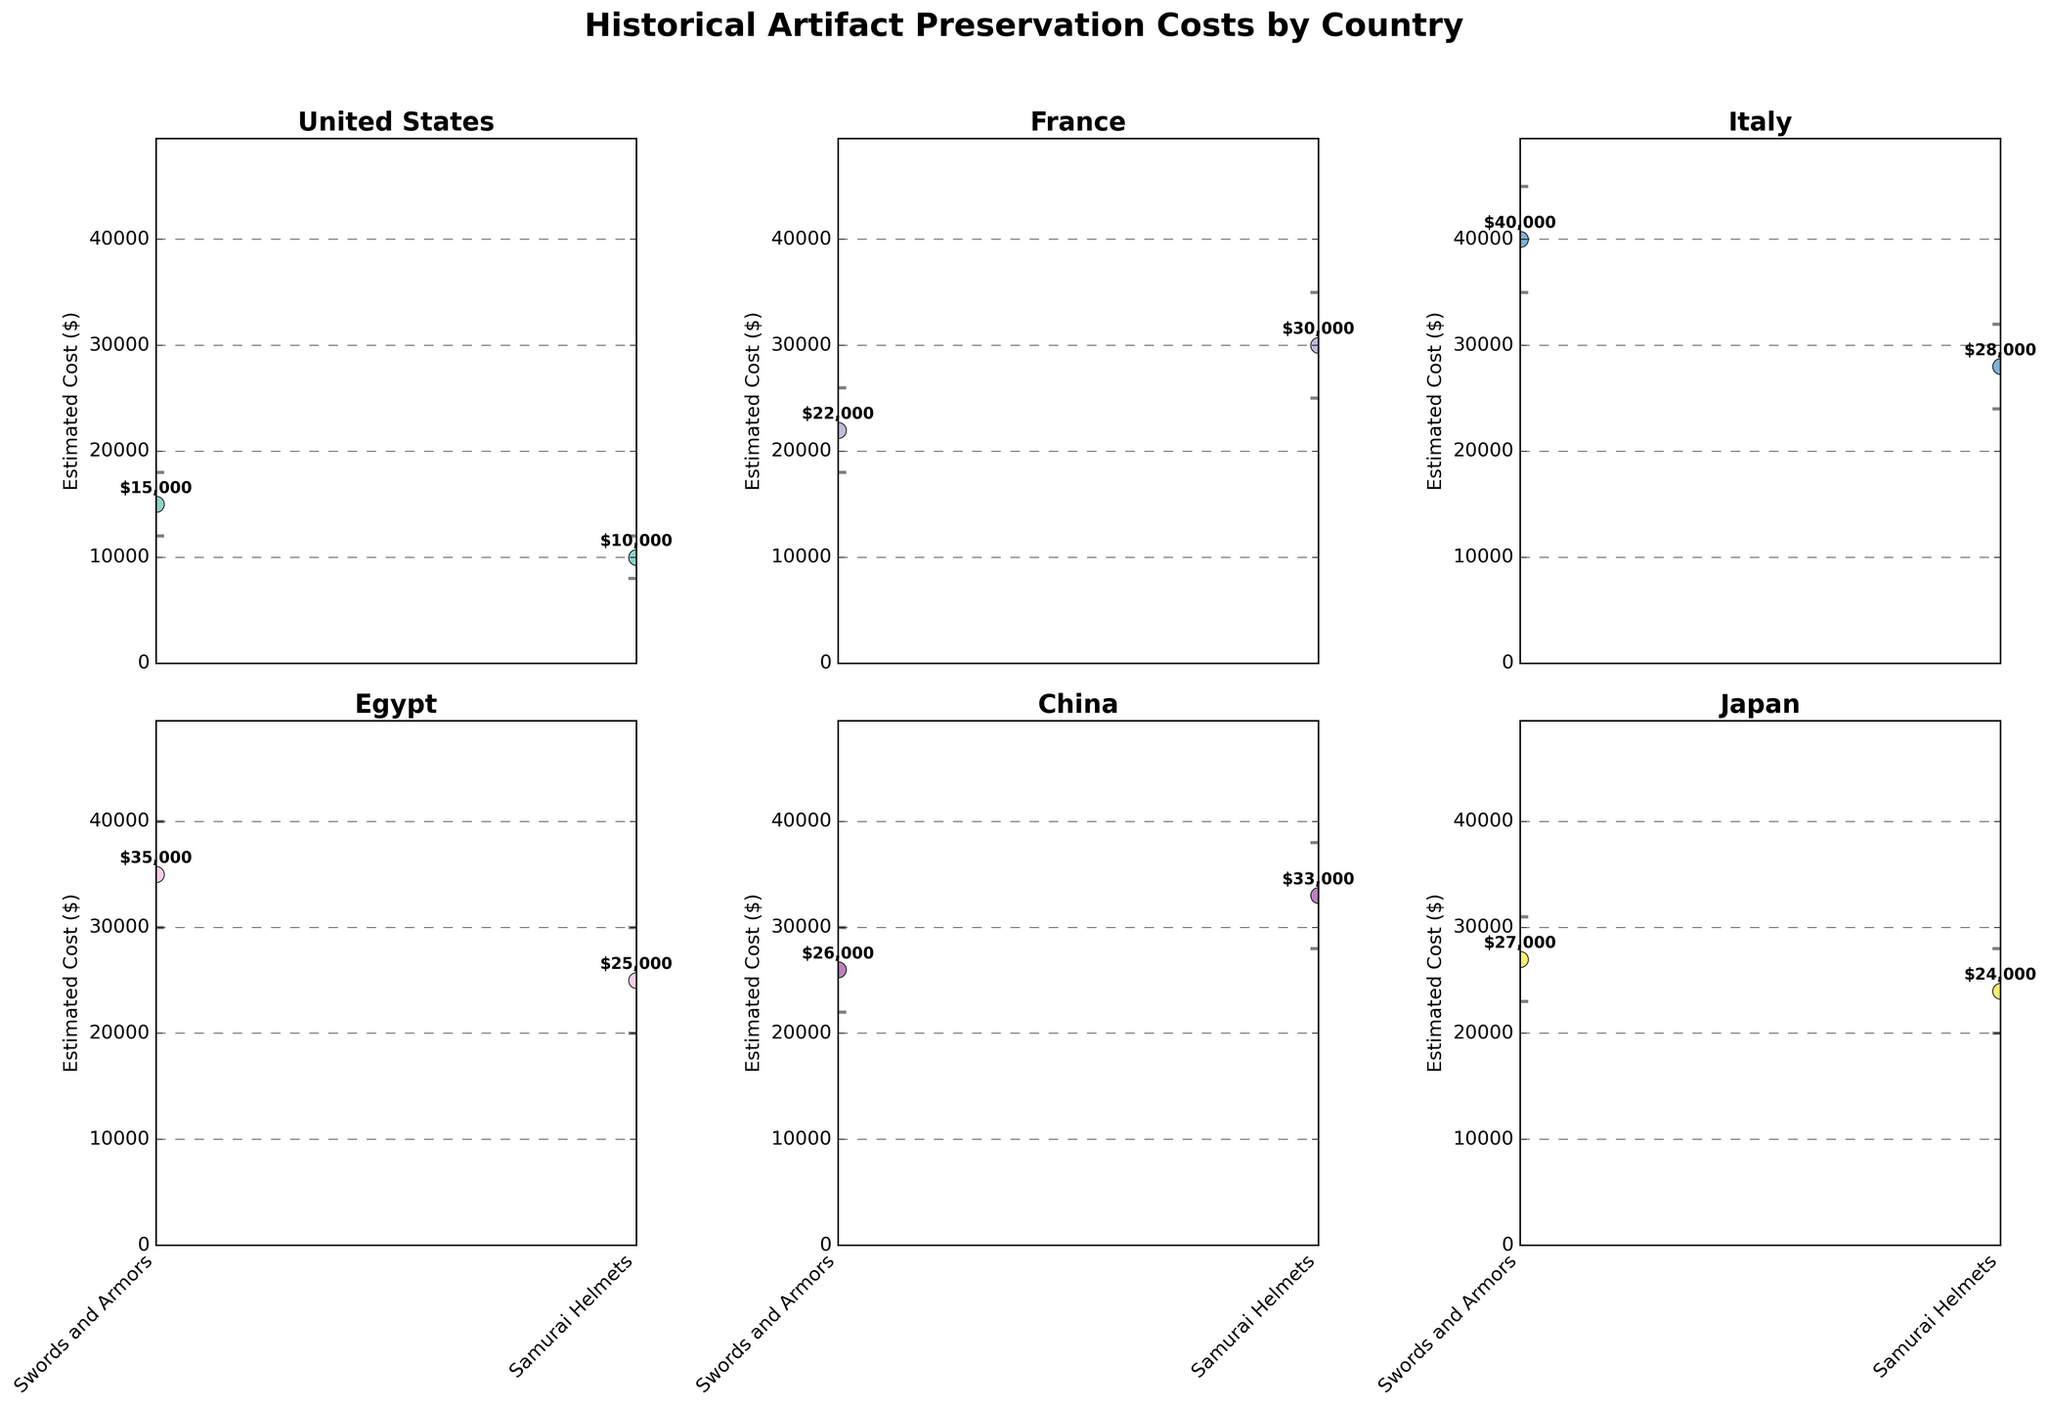What country has the highest estimated cost for preserving historical artifacts? The country with the highest estimated preservation cost is Italy, specifically for Roman Statues at $40,000. This can be seen from the plot of Italy where the Roman Statues have the highest data point.
Answer: Italy What is the range of the estimated preservation costs for Renaissance Paintings in France? The range of estimated preservation costs is determined by the difference between the upper and lower bounds of the confidence interval. For Renaissance Paintings in France, the upper bound is $35,000 and the lower bound is $25,000, so the range is $35,000 - $25,000 = $10,000.
Answer: $10,000 Which artifact type has the lowest estimated preservation cost in the United States? Referring to the plot for the United States, Colonial Documents have the lowest estimated preservation cost at $10,000.
Answer: Colonial Documents Compare the estimated preservation costs of Samurai Helmets in Japan and Bronze Artifacts in China. Which one is higher? The estimated preservation cost for Samurai Helmets in Japan is $24,000, whereas for Bronze Artifacts in China it is $33,000. Therefore, the preservation cost for Bronze Artifacts in China is higher.
Answer: Bronze Artifacts in China What is the difference in estimated preservation costs between Pharaonic Jewelry and Papyrus Manuscripts in Egypt? The estimated preservation cost for Pharaonic Jewelry is $35,000, and for Papyrus Manuscripts, it is $25,000. The difference is $35,000 - $25,000 = $10,000.
Answer: $10,000 What is the average estimated preservation cost of historical artifacts in China? To find the average estimated preservation cost of artifacts in China, we add the costs of Ancient Porcelain ($26,000) and Bronze Artifacts ($33,000) and then divide by 2. So the average is ($26,000 + $33,000) / 2 = $29,500.
Answer: $29,500 How many artifact types in total are represented across all the countries? By counting the number of artifact types listed in each subplot, we find: United States (2), France (2), Italy (2), Egypt (2), China (2), and Japan (2). Adding these up, we get 2 + 2 + 2 + 2 + 2 + 2 = 12.
Answer: 12 Which country has the least variation in preservation costs among its artifacts, based on confidence interval length? By examining the lengths of confidence intervals for each artifact in each country, the United States has the smallest intervals: Ancient Pottery ($6,000) and Colonial Documents ($4,000), showing least variation.
Answer: United States How does the preservation cost for Ancient Pottery in the United States compare to Medieval Tapestries in France? The estimated preservation cost for Ancient Pottery in the United States is $15,000, while for Medieval Tapestries in France it is $22,000. Medieval Tapestries in France have a higher preservation cost.
Answer: Medieval Tapestries in France 